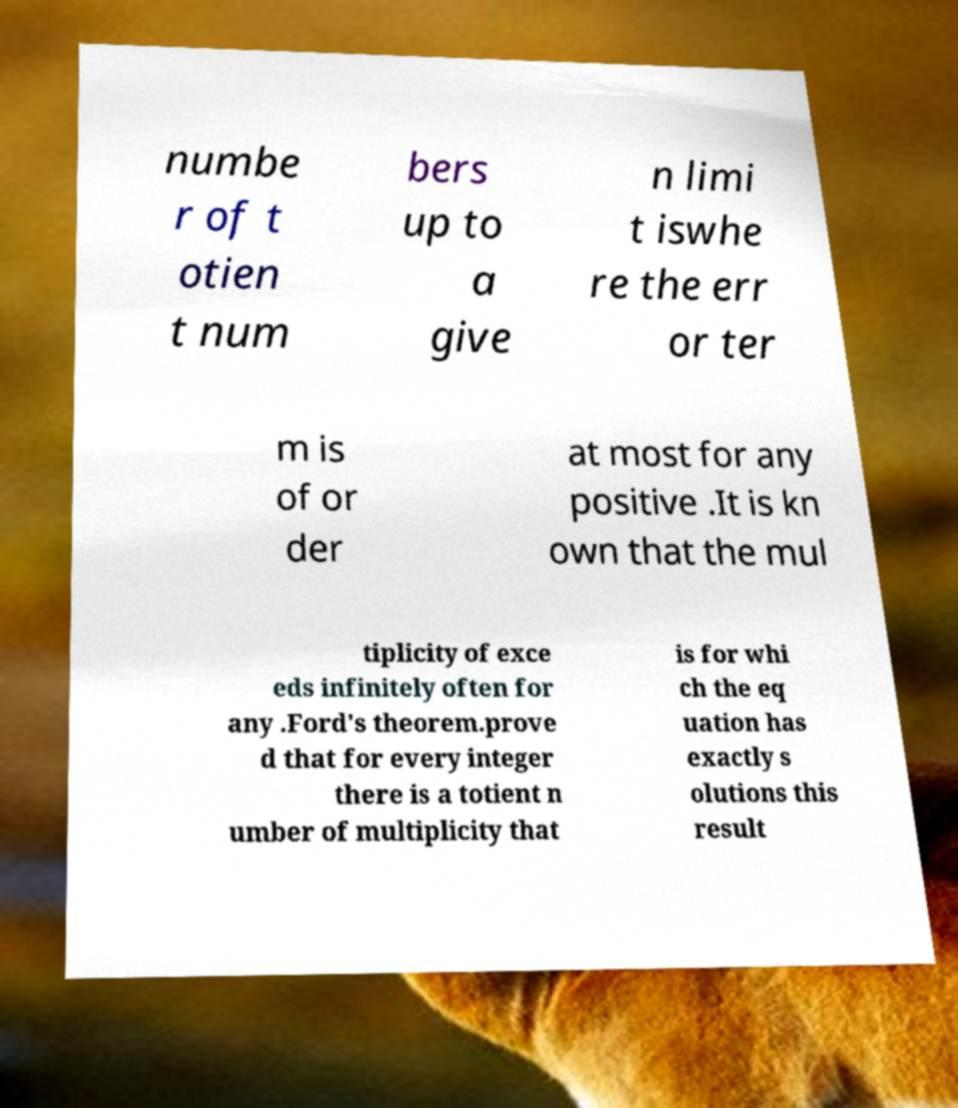For documentation purposes, I need the text within this image transcribed. Could you provide that? numbe r of t otien t num bers up to a give n limi t iswhe re the err or ter m is of or der at most for any positive .It is kn own that the mul tiplicity of exce eds infinitely often for any .Ford's theorem.prove d that for every integer there is a totient n umber of multiplicity that is for whi ch the eq uation has exactly s olutions this result 